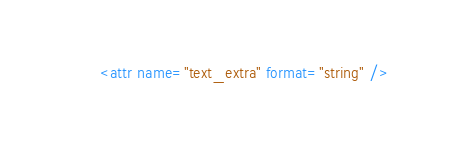Convert code to text. <code><loc_0><loc_0><loc_500><loc_500><_XML_>        <attr name="text_extra" format="string" /></code> 